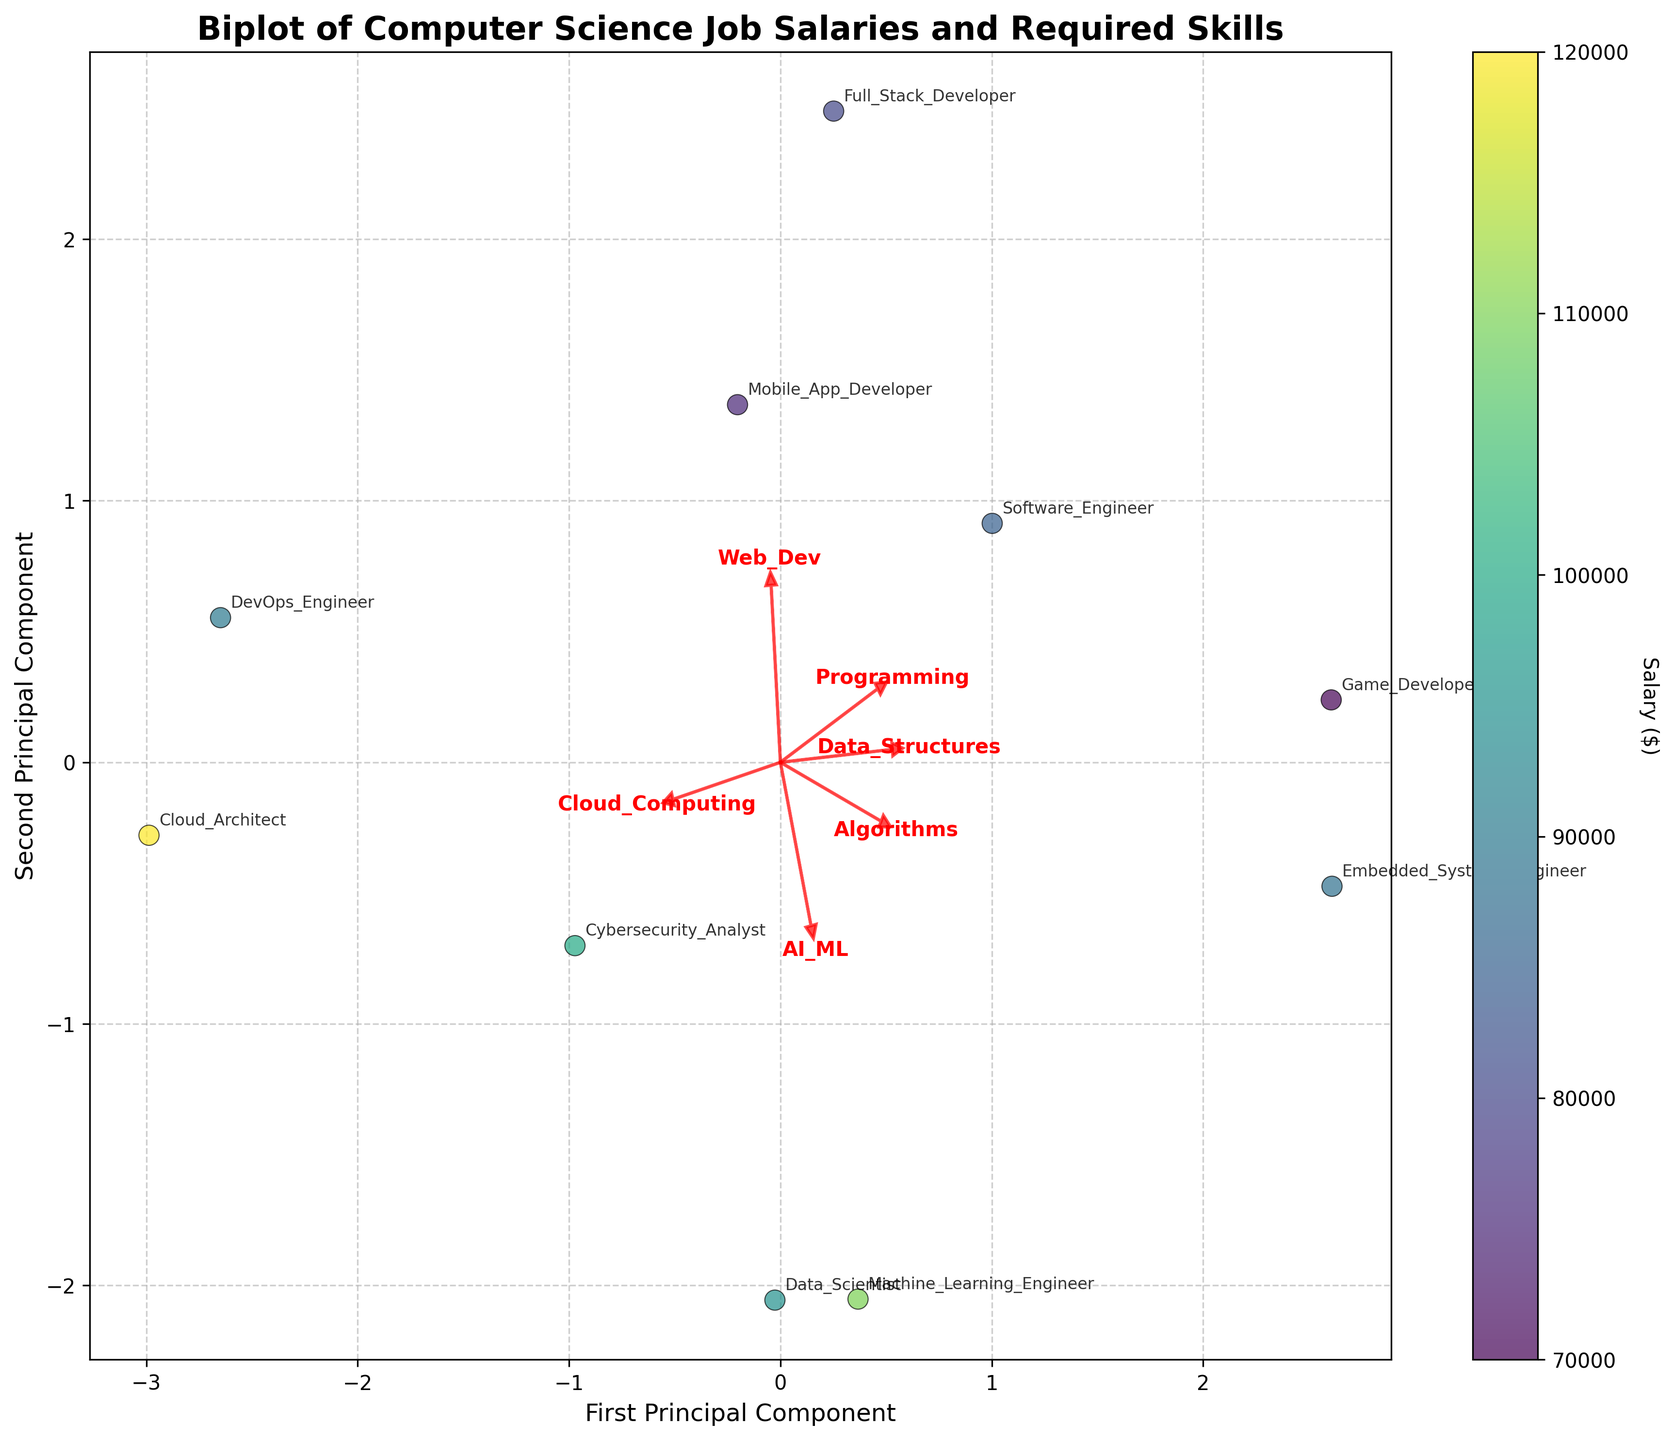What's the title of the biplot? The title of the biplot is mentioned at the top of the figure, which is 'Biplot of Computer Science Job Salaries and Required Skills'.
Answer: Biplot of Computer Science Job Salaries and Required Skills How many arrows (feature vectors) are there in the plot? Feature vectors are represented by arrows in the biplot, which correspond to the different skills. There are six skills: Programming, Data Structures, Algorithms, Web Dev, AI/ML, and Cloud Computing. Therefore, there are 6 arrows.
Answer: 6 Which job title is associated with the highest salary in the plot? The salaries are represented by the color intensity in the scatter plot. The highest salary is indicated by the job title 'Cloud Architect' which corresponds to a color towards the higher end of the color bar.
Answer: Cloud Architect What are the two principal components labeled on the axes? The x-axis is labeled 'First Principal Component' and the y-axis is labeled 'Second Principal Component', as indicated in the figure.
Answer: First Principal Component, Second Principal Component Which job titles are closely located in the first principal component? The job titles that are closely located along the first principal component can be identified by their positions on the x-axis. 'Software Engineer', 'Machine Learning Engineer', and 'Embedded Systems Engineer' are closer to each other along the first principal component.
Answer: Software Engineer, Machine Learning Engineer, Embedded Systems Engineer What is the total number of job titles shown in the plot? Each job title is represented by a scatter point. By counting the annotations, we find there are 10 job titles shown in the plot.
Answer: 10 Which skills are more positively correlated with each other based on the direction of the arrows? The arrows representing Programming, Data Structures, and Algorithms point in similar directions, indicating that these skills are more positively correlated with each other.
Answer: Programming, Data Structures, Algorithms Which industry seems to have a high average salary based on the color intensity of the points? Points representing jobs in the Consulting industry (Cloud Architect) and Healthcare (Machine Learning Engineer) have higher average salaries as indicated by the color intensity corresponding to these jobs.
Answer: Consulting, Healthcare What skills does the 'Data Scientist' job title heavily rely on according to the biplot? The 'Data Scientist' job title is annotated near the arrows representing AI/ML and Cloud Computing, suggesting that these are the skills that the job heavily relies on.
Answer: AI/ML, Cloud Computing Is the 'Full Stack Developer' job more associated with Web Development or Algorithms based on the direction of the arrows? The 'Full Stack Developer' is located closer to the arrow representing Web Dev, indicating it is more associated with Web Development.
Answer: Web Development 